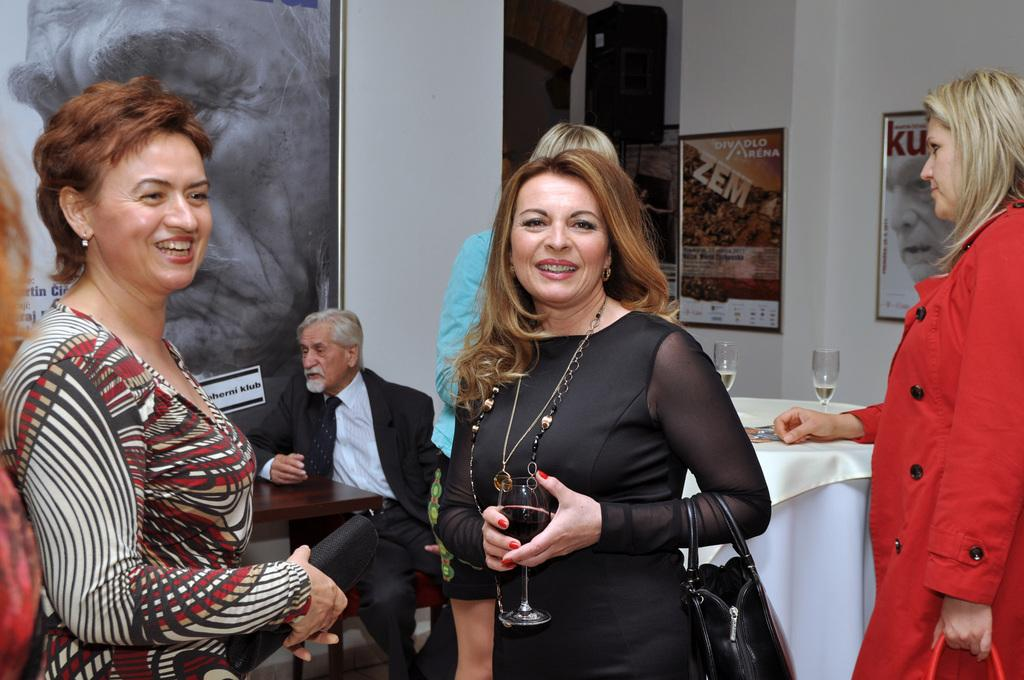What is the color of the wall in the image? The wall in the image is white. What can be seen hanging on the wall? There is a photo frame in the image. Who or what is present in the image? There are people in the image. What piece of furniture is visible in the image? There is a table in the image. What objects are on the table? There are glasses on the table. Can you tell me how many books are in the pail in the image? There is no pail or books present in the image. What type of fiction is being read by the people in the image? There is no indication of any reading material or fiction in the image. 